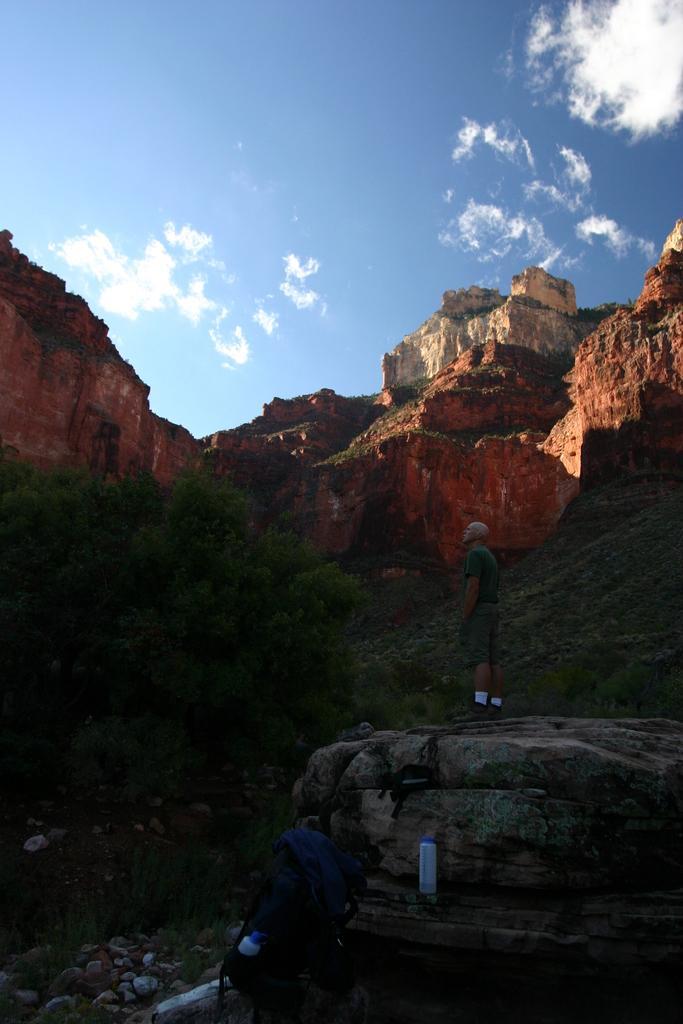In one or two sentences, can you explain what this image depicts? In the foreground I can see a person is standing on the rock and a bag. In the background I can see trees, mountains. On the top I can see the sky. This image is taken during a sunny day. 